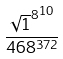<formula> <loc_0><loc_0><loc_500><loc_500>\frac { { \sqrt { 1 } ^ { 8 } } ^ { 1 0 } } { 4 6 8 ^ { 3 7 2 } }</formula> 